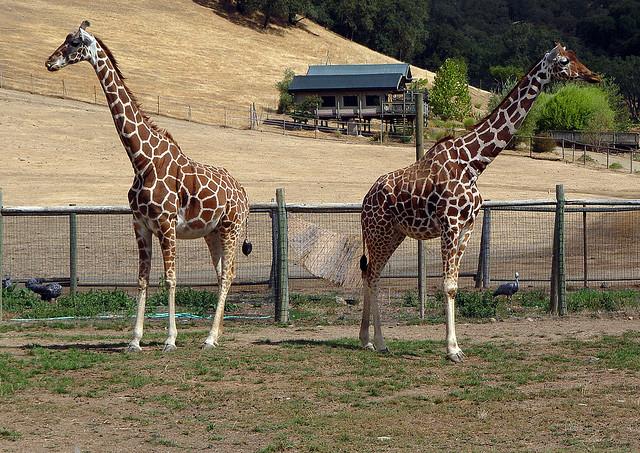Are the two animals close in age?
Write a very short answer. Yes. Are these animals enclosed?
Short answer required. Yes. Are both of these animals adults?
Concise answer only. Yes. How many animals are there?
Write a very short answer. 2. Are all the giraffes the same height?
Quick response, please. Yes. What is the fence post made of?
Quick response, please. Metal. Is the an outdoor picture?
Answer briefly. Yes. What is laying on the ground near the giraffes?
Answer briefly. Grass. Are these giraffes facing each other?
Keep it brief. No. What is the fence made of?
Give a very brief answer. Wood and wire. Are the giraffe's contained?
Be succinct. Yes. Are the giraffes resting?
Keep it brief. No. How many giraffes are there?
Write a very short answer. 2. Is one giraffe bigger than the other?
Keep it brief. No. 